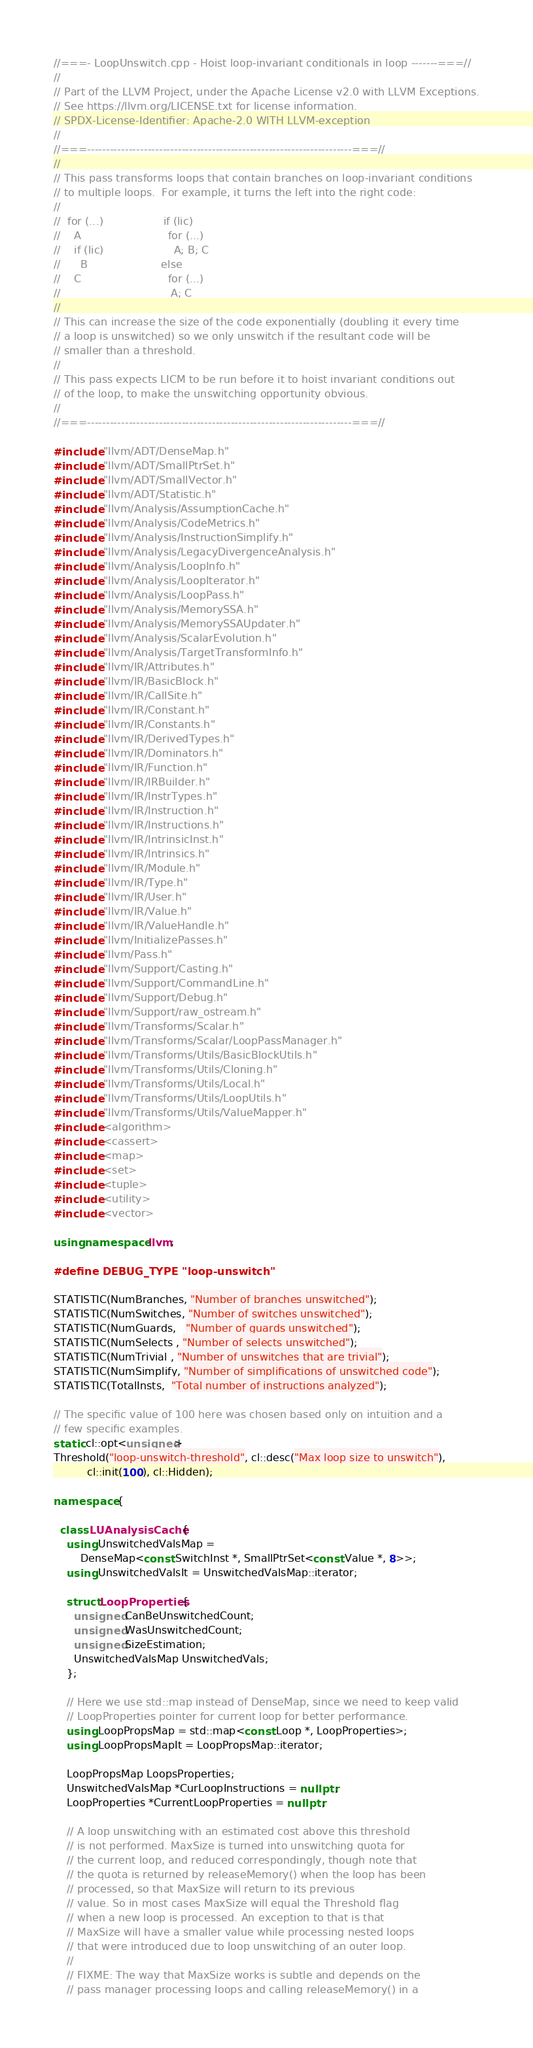Convert code to text. <code><loc_0><loc_0><loc_500><loc_500><_C++_>//===- LoopUnswitch.cpp - Hoist loop-invariant conditionals in loop -------===//
//
// Part of the LLVM Project, under the Apache License v2.0 with LLVM Exceptions.
// See https://llvm.org/LICENSE.txt for license information.
// SPDX-License-Identifier: Apache-2.0 WITH LLVM-exception
//
//===----------------------------------------------------------------------===//
//
// This pass transforms loops that contain branches on loop-invariant conditions
// to multiple loops.  For example, it turns the left into the right code:
//
//  for (...)                  if (lic)
//    A                          for (...)
//    if (lic)                     A; B; C
//      B                      else
//    C                          for (...)
//                                 A; C
//
// This can increase the size of the code exponentially (doubling it every time
// a loop is unswitched) so we only unswitch if the resultant code will be
// smaller than a threshold.
//
// This pass expects LICM to be run before it to hoist invariant conditions out
// of the loop, to make the unswitching opportunity obvious.
//
//===----------------------------------------------------------------------===//

#include "llvm/ADT/DenseMap.h"
#include "llvm/ADT/SmallPtrSet.h"
#include "llvm/ADT/SmallVector.h"
#include "llvm/ADT/Statistic.h"
#include "llvm/Analysis/AssumptionCache.h"
#include "llvm/Analysis/CodeMetrics.h"
#include "llvm/Analysis/InstructionSimplify.h"
#include "llvm/Analysis/LegacyDivergenceAnalysis.h"
#include "llvm/Analysis/LoopInfo.h"
#include "llvm/Analysis/LoopIterator.h"
#include "llvm/Analysis/LoopPass.h"
#include "llvm/Analysis/MemorySSA.h"
#include "llvm/Analysis/MemorySSAUpdater.h"
#include "llvm/Analysis/ScalarEvolution.h"
#include "llvm/Analysis/TargetTransformInfo.h"
#include "llvm/IR/Attributes.h"
#include "llvm/IR/BasicBlock.h"
#include "llvm/IR/CallSite.h"
#include "llvm/IR/Constant.h"
#include "llvm/IR/Constants.h"
#include "llvm/IR/DerivedTypes.h"
#include "llvm/IR/Dominators.h"
#include "llvm/IR/Function.h"
#include "llvm/IR/IRBuilder.h"
#include "llvm/IR/InstrTypes.h"
#include "llvm/IR/Instruction.h"
#include "llvm/IR/Instructions.h"
#include "llvm/IR/IntrinsicInst.h"
#include "llvm/IR/Intrinsics.h"
#include "llvm/IR/Module.h"
#include "llvm/IR/Type.h"
#include "llvm/IR/User.h"
#include "llvm/IR/Value.h"
#include "llvm/IR/ValueHandle.h"
#include "llvm/InitializePasses.h"
#include "llvm/Pass.h"
#include "llvm/Support/Casting.h"
#include "llvm/Support/CommandLine.h"
#include "llvm/Support/Debug.h"
#include "llvm/Support/raw_ostream.h"
#include "llvm/Transforms/Scalar.h"
#include "llvm/Transforms/Scalar/LoopPassManager.h"
#include "llvm/Transforms/Utils/BasicBlockUtils.h"
#include "llvm/Transforms/Utils/Cloning.h"
#include "llvm/Transforms/Utils/Local.h"
#include "llvm/Transforms/Utils/LoopUtils.h"
#include "llvm/Transforms/Utils/ValueMapper.h"
#include <algorithm>
#include <cassert>
#include <map>
#include <set>
#include <tuple>
#include <utility>
#include <vector>

using namespace llvm;

#define DEBUG_TYPE "loop-unswitch"

STATISTIC(NumBranches, "Number of branches unswitched");
STATISTIC(NumSwitches, "Number of switches unswitched");
STATISTIC(NumGuards,   "Number of guards unswitched");
STATISTIC(NumSelects , "Number of selects unswitched");
STATISTIC(NumTrivial , "Number of unswitches that are trivial");
STATISTIC(NumSimplify, "Number of simplifications of unswitched code");
STATISTIC(TotalInsts,  "Total number of instructions analyzed");

// The specific value of 100 here was chosen based only on intuition and a
// few specific examples.
static cl::opt<unsigned>
Threshold("loop-unswitch-threshold", cl::desc("Max loop size to unswitch"),
          cl::init(100), cl::Hidden);

namespace {

  class LUAnalysisCache {
    using UnswitchedValsMap =
        DenseMap<const SwitchInst *, SmallPtrSet<const Value *, 8>>;
    using UnswitchedValsIt = UnswitchedValsMap::iterator;

    struct LoopProperties {
      unsigned CanBeUnswitchedCount;
      unsigned WasUnswitchedCount;
      unsigned SizeEstimation;
      UnswitchedValsMap UnswitchedVals;
    };

    // Here we use std::map instead of DenseMap, since we need to keep valid
    // LoopProperties pointer for current loop for better performance.
    using LoopPropsMap = std::map<const Loop *, LoopProperties>;
    using LoopPropsMapIt = LoopPropsMap::iterator;

    LoopPropsMap LoopsProperties;
    UnswitchedValsMap *CurLoopInstructions = nullptr;
    LoopProperties *CurrentLoopProperties = nullptr;

    // A loop unswitching with an estimated cost above this threshold
    // is not performed. MaxSize is turned into unswitching quota for
    // the current loop, and reduced correspondingly, though note that
    // the quota is returned by releaseMemory() when the loop has been
    // processed, so that MaxSize will return to its previous
    // value. So in most cases MaxSize will equal the Threshold flag
    // when a new loop is processed. An exception to that is that
    // MaxSize will have a smaller value while processing nested loops
    // that were introduced due to loop unswitching of an outer loop.
    //
    // FIXME: The way that MaxSize works is subtle and depends on the
    // pass manager processing loops and calling releaseMemory() in a</code> 